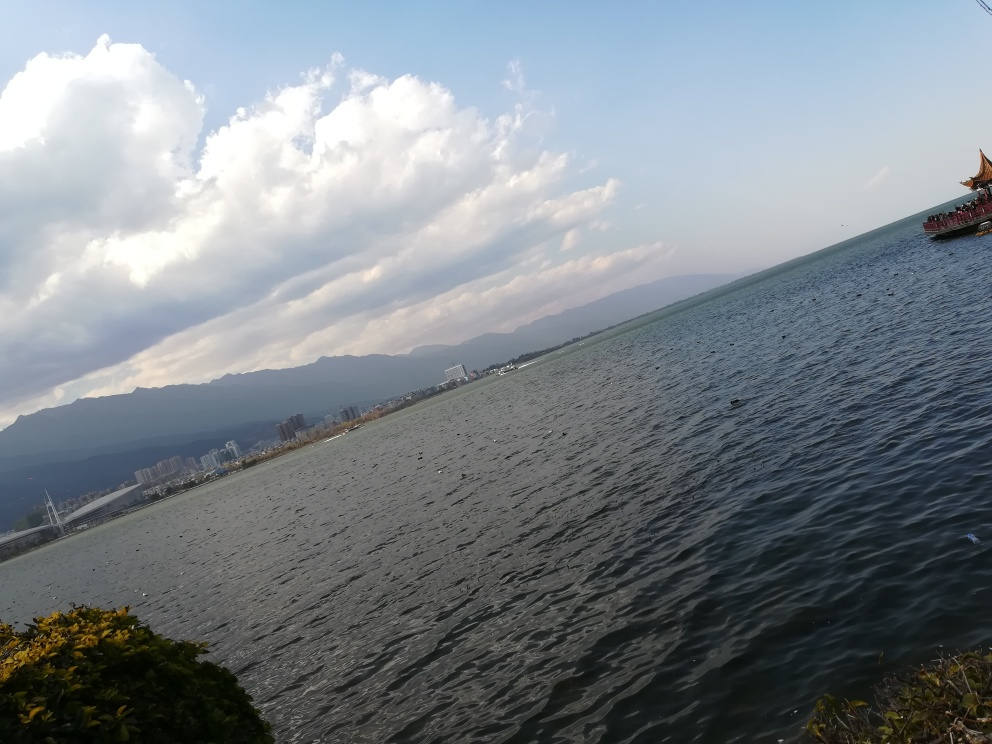Is the content of the image limited? The image depicts a body of water with a mountain range in the distance and a cloudy sky above. A section of greenery is visible in the foreground, and there appears to be a colorful, traditional-style boat on the right, suggesting this might be a popular lake or tourist area. The content of the image is not limited; it provides a scenic view that could invite questions related to the natural environment, the location's geography, the cultural significance of the boat, or the time of day the photograph was taken. 